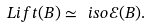Convert formula to latex. <formula><loc_0><loc_0><loc_500><loc_500>L i f t ( B ) \simeq \ i s o \mathcal { E } ( B ) .</formula> 